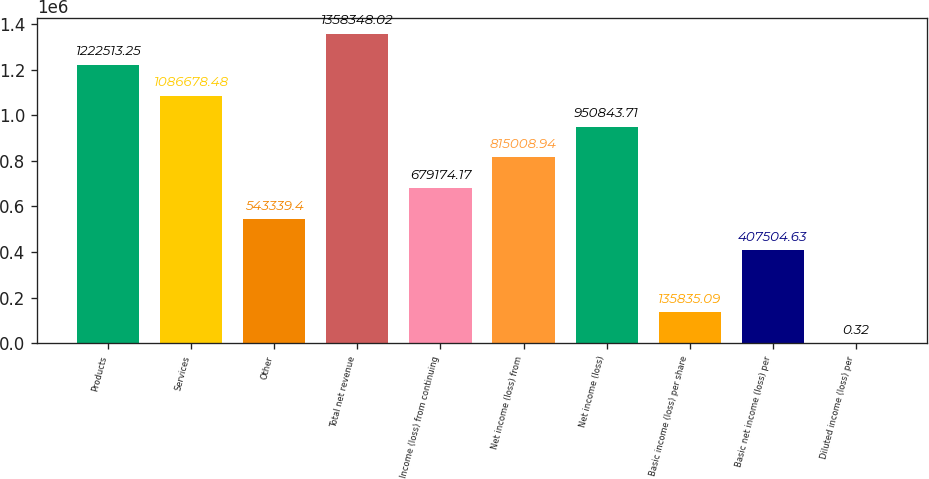Convert chart to OTSL. <chart><loc_0><loc_0><loc_500><loc_500><bar_chart><fcel>Products<fcel>Services<fcel>Other<fcel>Total net revenue<fcel>Income (loss) from continuing<fcel>Net income (loss) from<fcel>Net income (loss)<fcel>Basic income (loss) per share<fcel>Basic net income (loss) per<fcel>Diluted income (loss) per<nl><fcel>1.22251e+06<fcel>1.08668e+06<fcel>543339<fcel>1.35835e+06<fcel>679174<fcel>815009<fcel>950844<fcel>135835<fcel>407505<fcel>0.32<nl></chart> 